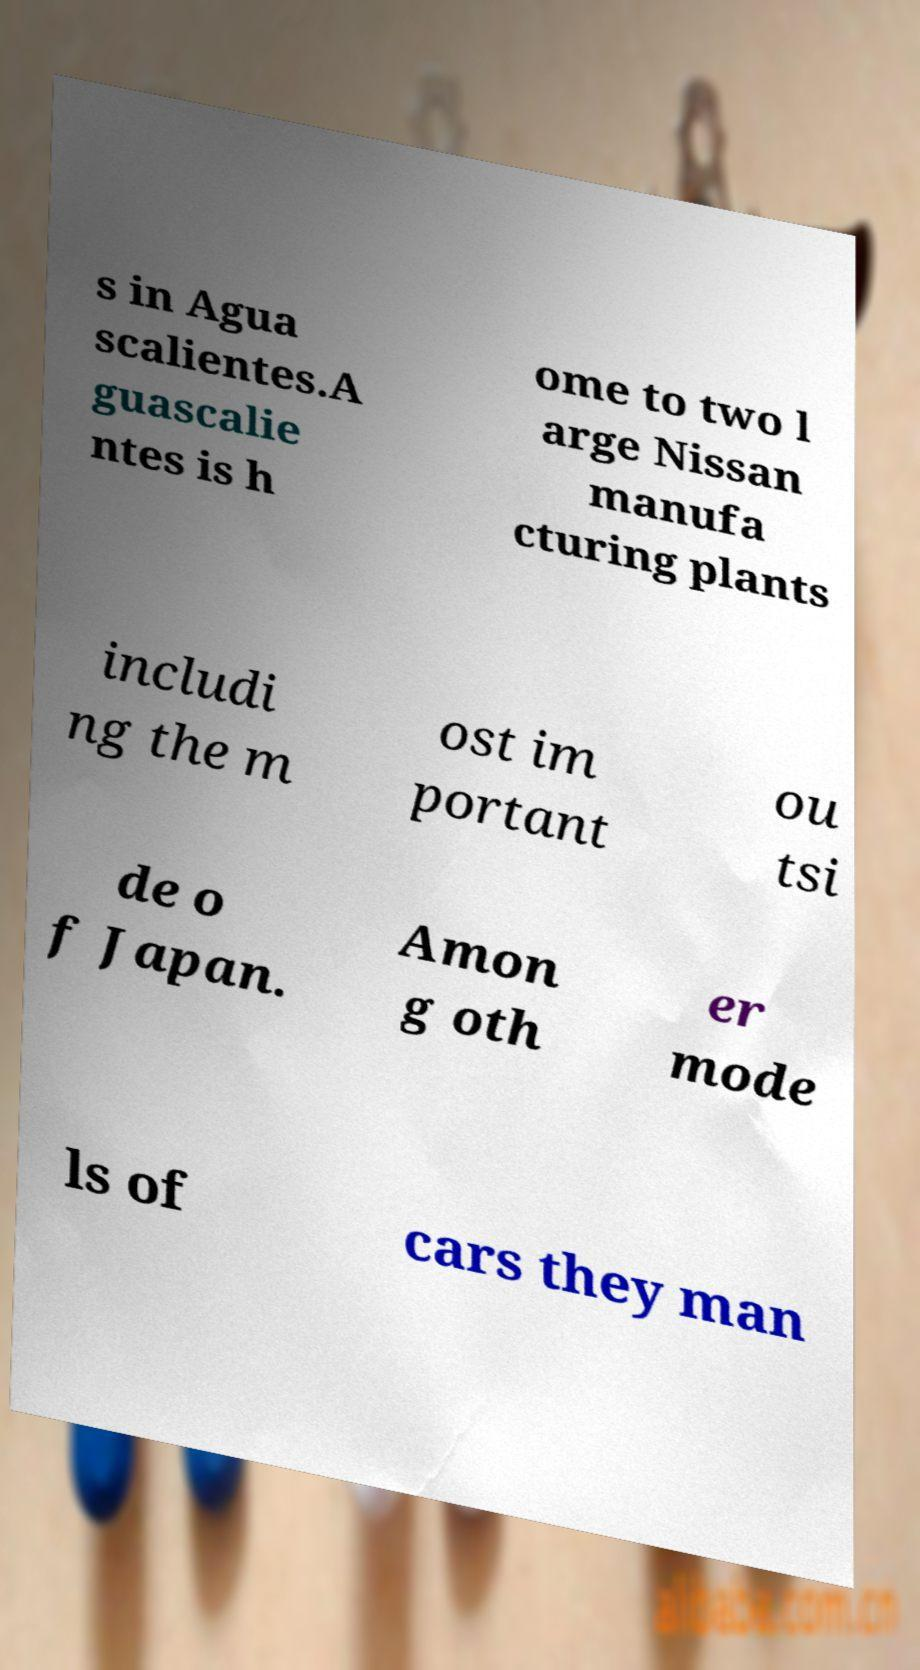Can you accurately transcribe the text from the provided image for me? s in Agua scalientes.A guascalie ntes is h ome to two l arge Nissan manufa cturing plants includi ng the m ost im portant ou tsi de o f Japan. Amon g oth er mode ls of cars they man 